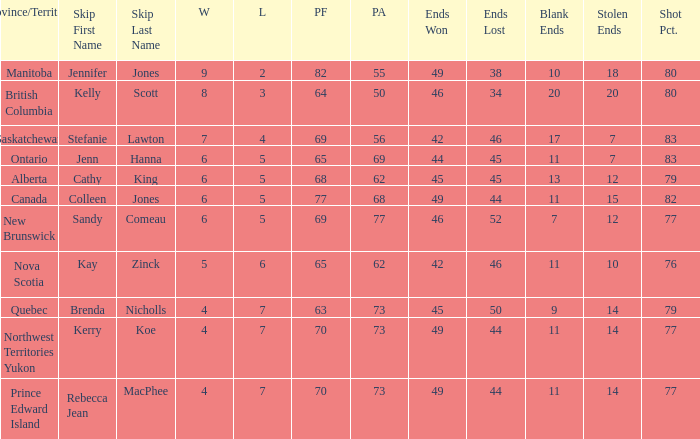What is the lowest PF? 63.0. 